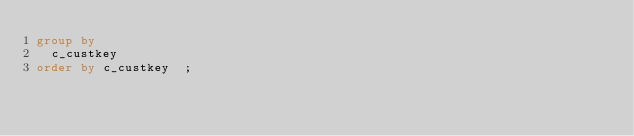Convert code to text. <code><loc_0><loc_0><loc_500><loc_500><_SQL_>group by
  c_custkey
order by c_custkey  ;</code> 